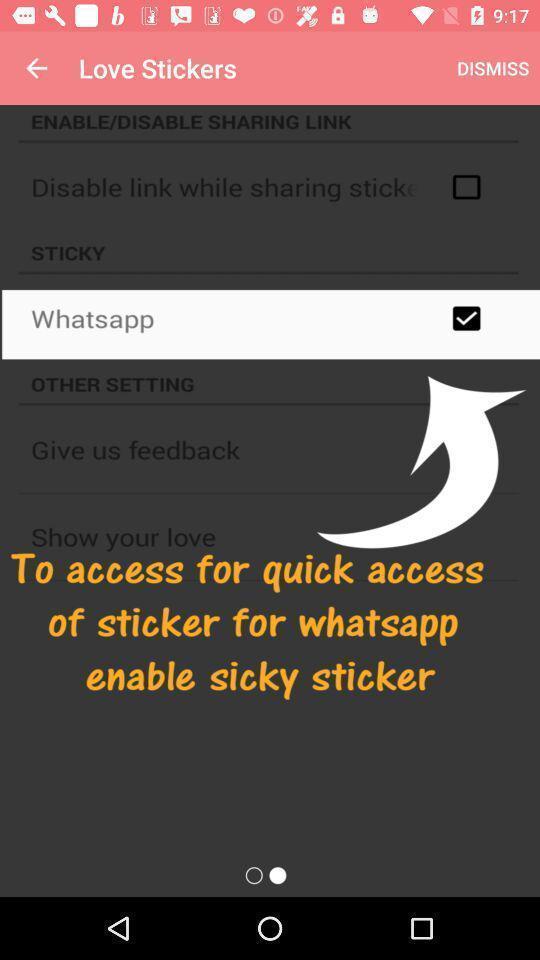Explain what's happening in this screen capture. Pop-up shows an option to access. 